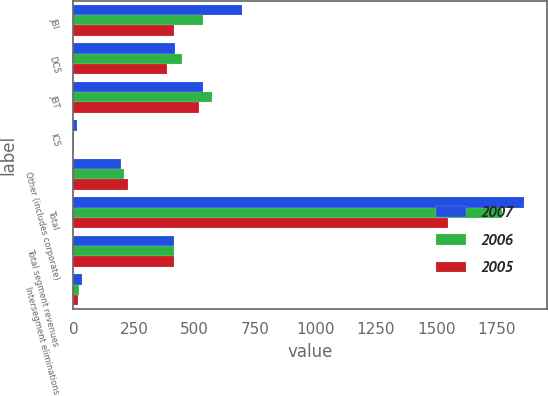Convert chart to OTSL. <chart><loc_0><loc_0><loc_500><loc_500><stacked_bar_chart><ecel><fcel>JBI<fcel>DCS<fcel>JBT<fcel>ICS<fcel>Other (includes corporate)<fcel>Total<fcel>Total segment revenues<fcel>Intersegment eliminations<nl><fcel>2007<fcel>695<fcel>421<fcel>535<fcel>16<fcel>196<fcel>1863<fcel>416<fcel>34<nl><fcel>2006<fcel>537<fcel>450<fcel>571<fcel>4<fcel>208<fcel>1770<fcel>416<fcel>25<nl><fcel>2005<fcel>416<fcel>386<fcel>519<fcel>3<fcel>225<fcel>1549<fcel>416<fcel>20<nl></chart> 